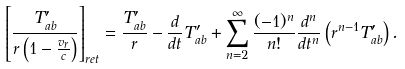<formula> <loc_0><loc_0><loc_500><loc_500>\left [ \frac { T ^ { \prime } _ { a b } } { r \left ( 1 - \frac { v _ { r } } { c } \right ) } \right ] _ { r e t } = \frac { T _ { a b } ^ { \prime } } { r } - \frac { d } { d t } T _ { a b } ^ { \prime } + \sum _ { n = 2 } ^ { \infty } \frac { ( - 1 ) ^ { n } } { n ! } \frac { d ^ { n } } { d t ^ { n } } \left ( r ^ { n - 1 } T ^ { \prime } _ { a b } \right ) .</formula> 